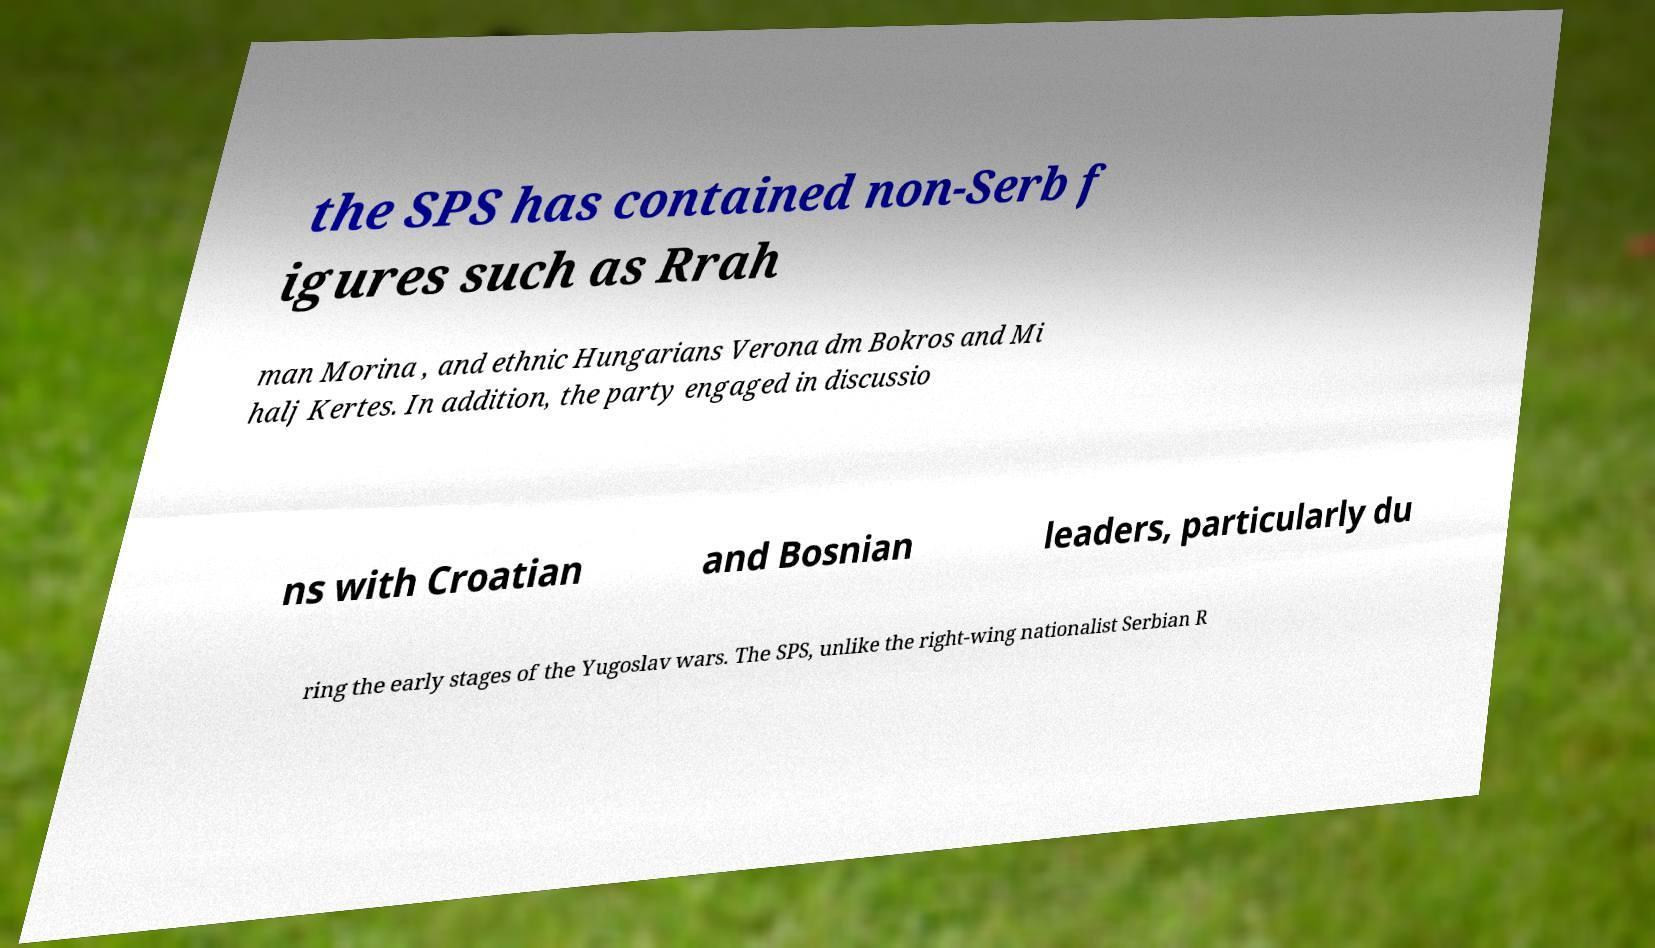Please identify and transcribe the text found in this image. the SPS has contained non-Serb f igures such as Rrah man Morina , and ethnic Hungarians Verona dm Bokros and Mi halj Kertes. In addition, the party engaged in discussio ns with Croatian and Bosnian leaders, particularly du ring the early stages of the Yugoslav wars. The SPS, unlike the right-wing nationalist Serbian R 